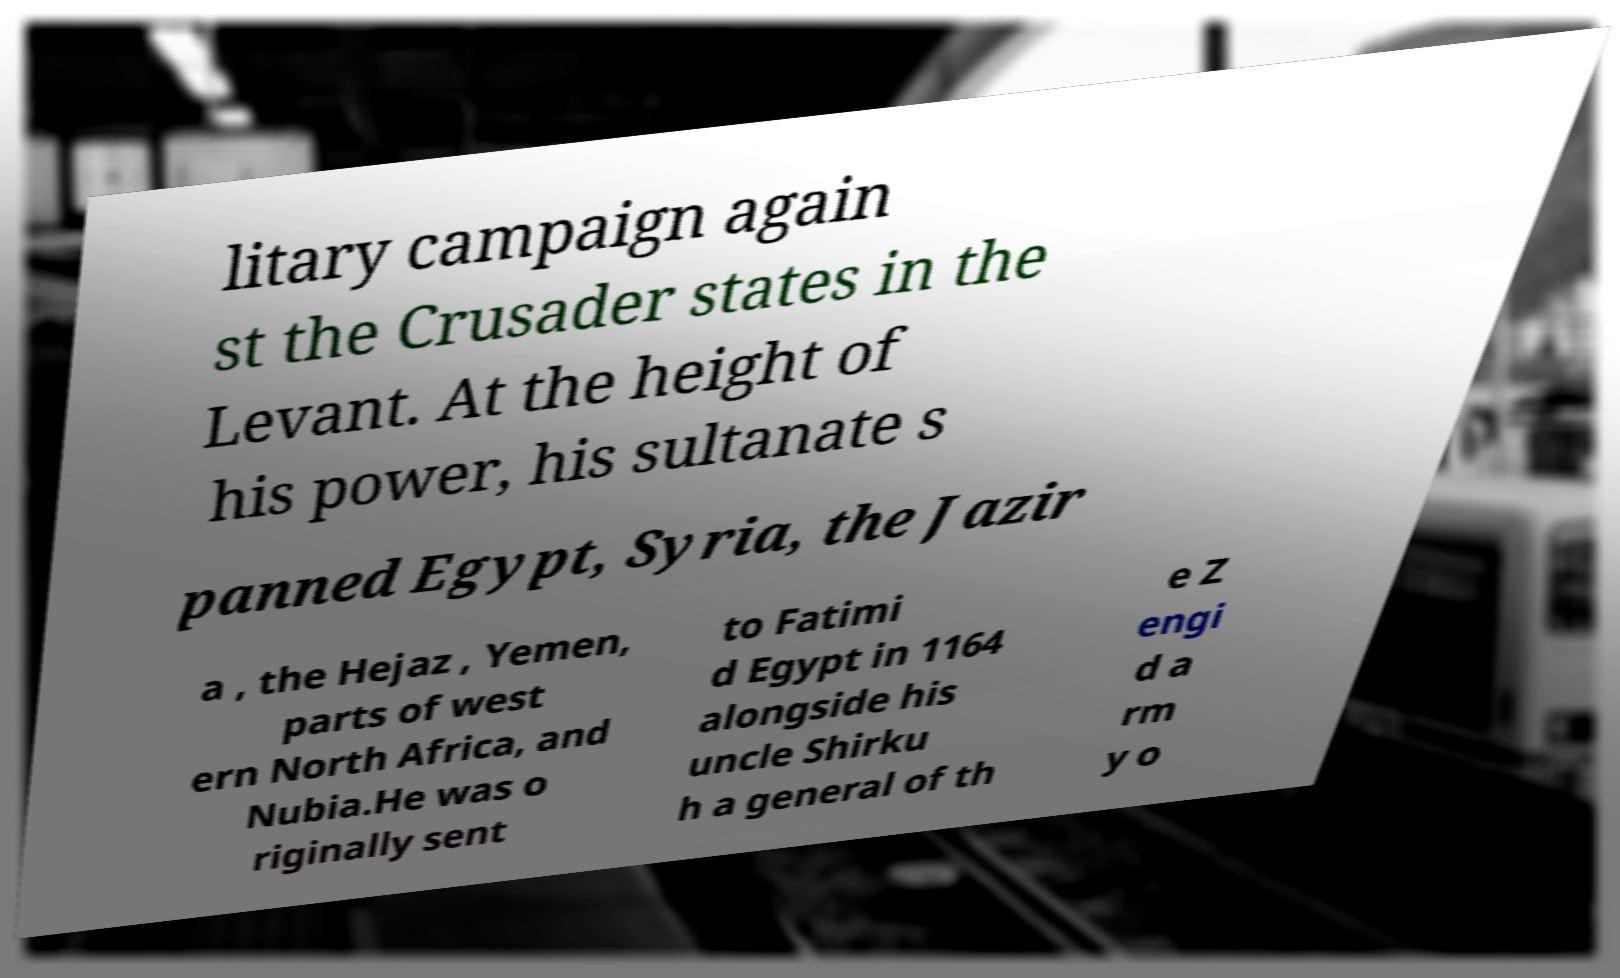What messages or text are displayed in this image? I need them in a readable, typed format. litary campaign again st the Crusader states in the Levant. At the height of his power, his sultanate s panned Egypt, Syria, the Jazir a , the Hejaz , Yemen, parts of west ern North Africa, and Nubia.He was o riginally sent to Fatimi d Egypt in 1164 alongside his uncle Shirku h a general of th e Z engi d a rm y o 